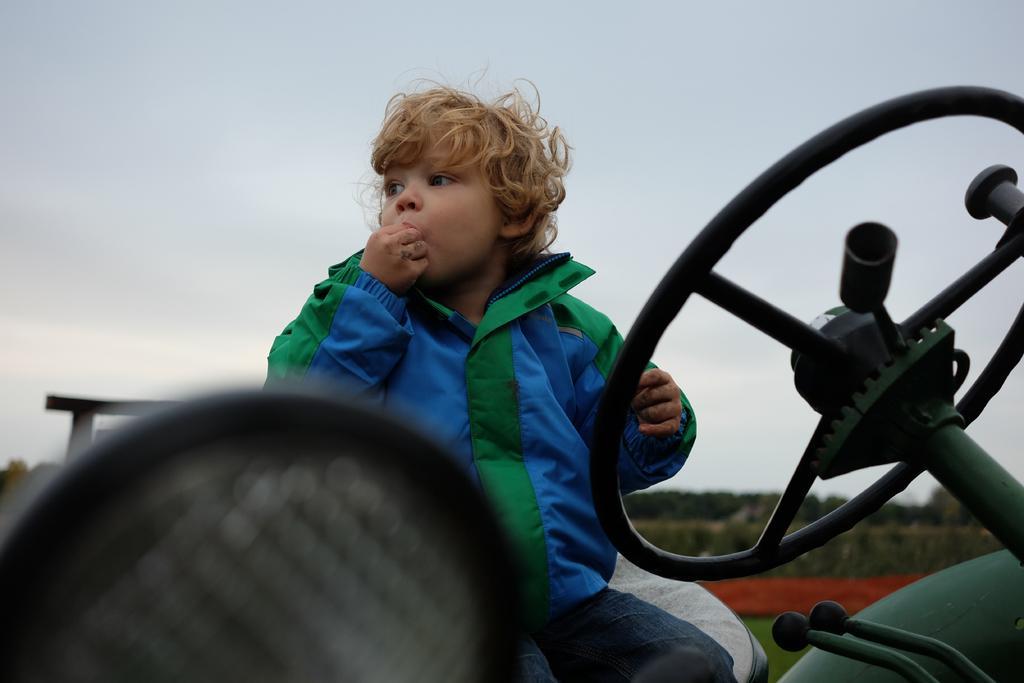How would you summarize this image in a sentence or two? In this image I can see a boy who is sitting on a vehicle and he kept one of his hand in the mouth and another hand near to the steering. In the background I see the clear sky. 